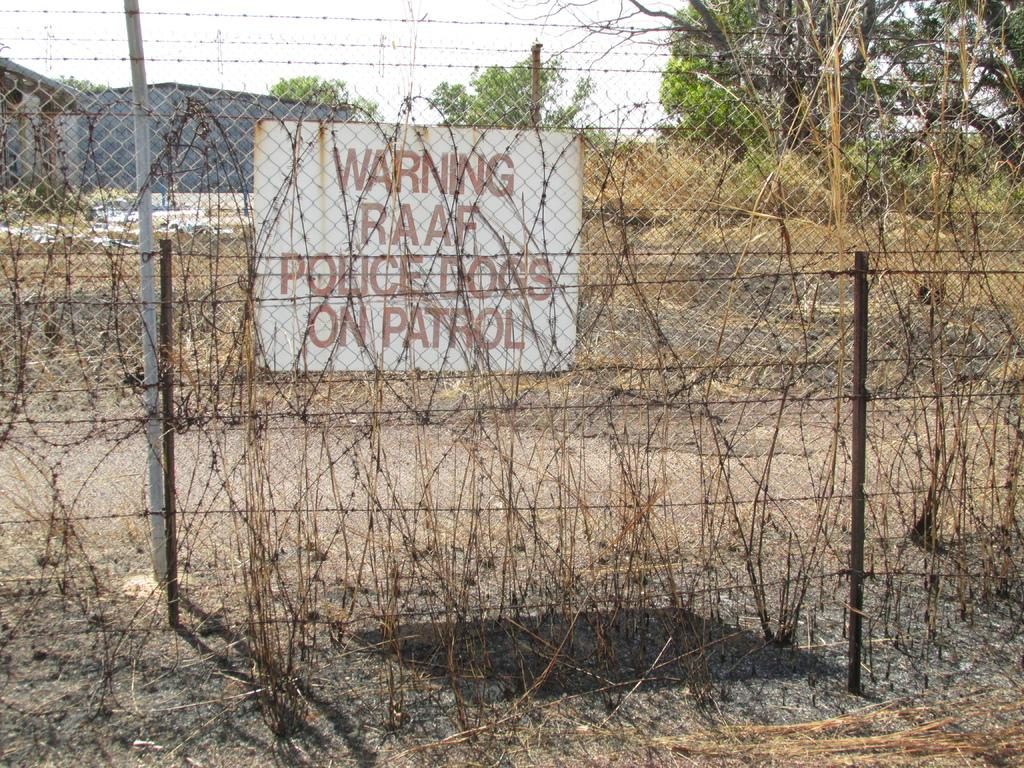What is the main object in the image? There is a board in the image. What other structures can be seen in the image? There is a fence and sheds in the image. What are the rods used for in the image? The rods in the image are used for supporting or connecting structures. What type of vegetation is present in the image? There are plants and trees in the image. What can be seen in the background of the image? The sky is visible in the background of the image. How many chairs are visible in the image? There are no chairs present in the image. What type of grass is growing in the yard in the image? There is no yard or grass present in the image. 